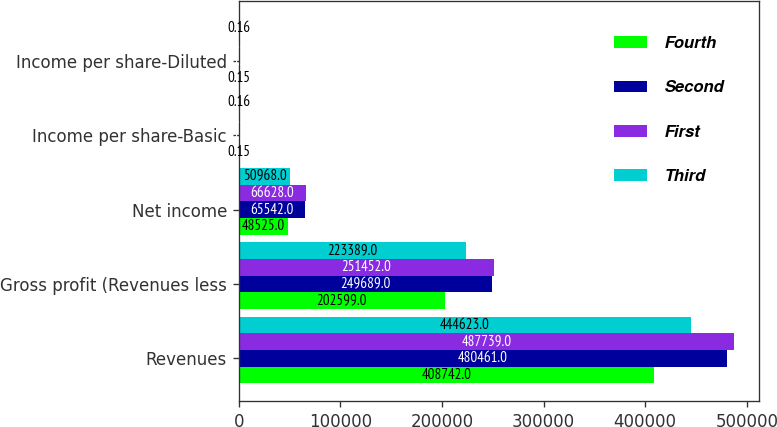Convert chart to OTSL. <chart><loc_0><loc_0><loc_500><loc_500><stacked_bar_chart><ecel><fcel>Revenues<fcel>Gross profit (Revenues less<fcel>Net income<fcel>Income per share-Basic<fcel>Income per share-Diluted<nl><fcel>Fourth<fcel>408742<fcel>202599<fcel>48525<fcel>0.15<fcel>0.15<nl><fcel>Second<fcel>480461<fcel>249689<fcel>65542<fcel>0.2<fcel>0.2<nl><fcel>First<fcel>487739<fcel>251452<fcel>66628<fcel>0.2<fcel>0.2<nl><fcel>Third<fcel>444623<fcel>223389<fcel>50968<fcel>0.16<fcel>0.16<nl></chart> 